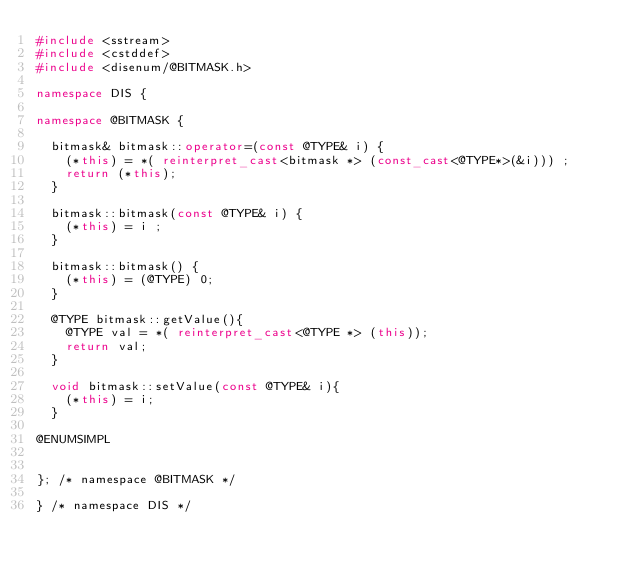Convert code to text. <code><loc_0><loc_0><loc_500><loc_500><_C++_>#include <sstream>
#include <cstddef>
#include <disenum/@BITMASK.h>

namespace DIS {

namespace @BITMASK {

  bitmask& bitmask::operator=(const @TYPE& i) {
    (*this) = *( reinterpret_cast<bitmask *> (const_cast<@TYPE*>(&i))) ;
	  return (*this);
  }

  bitmask::bitmask(const @TYPE& i) {
    (*this) = i ;
  }

  bitmask::bitmask() {
    (*this) = (@TYPE) 0;
  }

  @TYPE bitmask::getValue(){
    @TYPE val = *( reinterpret_cast<@TYPE *> (this));
    return val;
  }

  void bitmask::setValue(const @TYPE& i){
	  (*this) = i;
  }

@ENUMSIMPL


}; /* namespace @BITMASK */

} /* namespace DIS */
</code> 